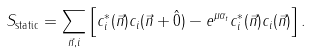Convert formula to latex. <formula><loc_0><loc_0><loc_500><loc_500>S _ { \text {static} } = \sum _ { \vec { n } , i } \left [ c _ { i } ^ { \ast } ( \vec { n } ) c _ { i } ( \vec { n } + \hat { 0 } ) - e ^ { \mu \alpha _ { t } } c _ { i } ^ { \ast } ( \vec { n } ) c _ { i } ( \vec { n } ) \right ] .</formula> 